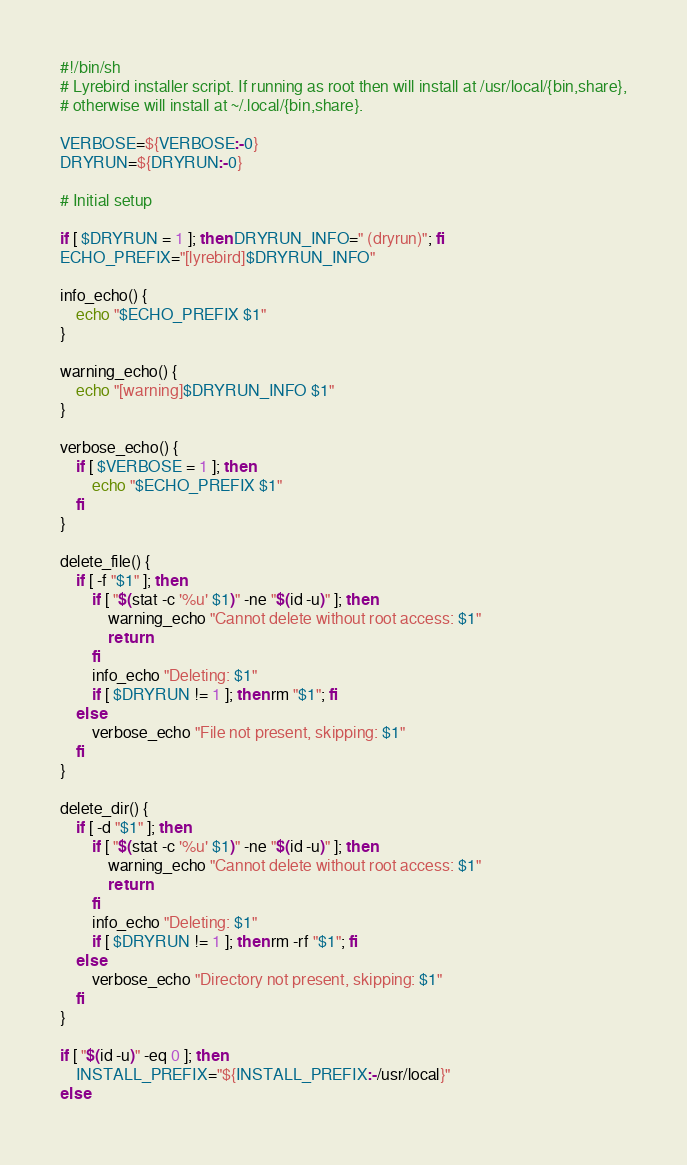Convert code to text. <code><loc_0><loc_0><loc_500><loc_500><_Bash_>#!/bin/sh
# Lyrebird installer script. If running as root then will install at /usr/local/{bin,share},
# otherwise will install at ~/.local/{bin,share}.

VERBOSE=${VERBOSE:-0}
DRYRUN=${DRYRUN:-0}

# Initial setup

if [ $DRYRUN = 1 ]; then DRYRUN_INFO=" (dryrun)"; fi
ECHO_PREFIX="[lyrebird]$DRYRUN_INFO"

info_echo() {
    echo "$ECHO_PREFIX $1"
}

warning_echo() {
    echo "[warning]$DRYRUN_INFO $1"
}

verbose_echo() {
    if [ $VERBOSE = 1 ]; then
        echo "$ECHO_PREFIX $1"
    fi
}

delete_file() {
    if [ -f "$1" ]; then
        if [ "$(stat -c '%u' $1)" -ne "$(id -u)" ]; then
            warning_echo "Cannot delete without root access: $1"
            return
        fi
        info_echo "Deleting: $1"
        if [ $DRYRUN != 1 ]; then rm "$1"; fi
    else
        verbose_echo "File not present, skipping: $1"
    fi
}

delete_dir() {
    if [ -d "$1" ]; then
        if [ "$(stat -c '%u' $1)" -ne "$(id -u)" ]; then
            warning_echo "Cannot delete without root access: $1"
            return
        fi
        info_echo "Deleting: $1"
        if [ $DRYRUN != 1 ]; then rm -rf "$1"; fi
    else
        verbose_echo "Directory not present, skipping: $1"
    fi
}

if [ "$(id -u)" -eq 0 ]; then
    INSTALL_PREFIX="${INSTALL_PREFIX:-/usr/local}"
else</code> 